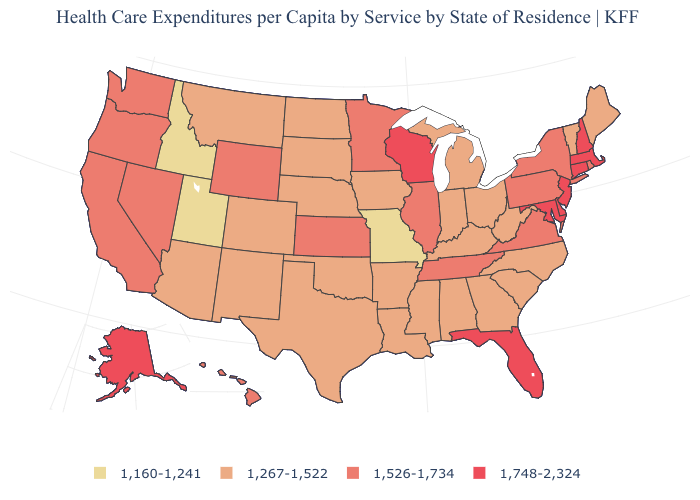Does Utah have the lowest value in the USA?
Write a very short answer. Yes. Name the states that have a value in the range 1,526-1,734?
Be succinct. California, Hawaii, Illinois, Kansas, Minnesota, Nevada, New York, Oregon, Pennsylvania, Rhode Island, Tennessee, Virginia, Washington, Wyoming. Which states have the lowest value in the USA?
Short answer required. Idaho, Missouri, Utah. Which states have the highest value in the USA?
Answer briefly. Alaska, Connecticut, Delaware, Florida, Maryland, Massachusetts, New Hampshire, New Jersey, Wisconsin. Which states hav the highest value in the MidWest?
Be succinct. Wisconsin. What is the value of Florida?
Short answer required. 1,748-2,324. Which states hav the highest value in the MidWest?
Quick response, please. Wisconsin. What is the value of Alaska?
Give a very brief answer. 1,748-2,324. What is the value of New Jersey?
Keep it brief. 1,748-2,324. Name the states that have a value in the range 1,267-1,522?
Quick response, please. Alabama, Arizona, Arkansas, Colorado, Georgia, Indiana, Iowa, Kentucky, Louisiana, Maine, Michigan, Mississippi, Montana, Nebraska, New Mexico, North Carolina, North Dakota, Ohio, Oklahoma, South Carolina, South Dakota, Texas, Vermont, West Virginia. Name the states that have a value in the range 1,267-1,522?
Short answer required. Alabama, Arizona, Arkansas, Colorado, Georgia, Indiana, Iowa, Kentucky, Louisiana, Maine, Michigan, Mississippi, Montana, Nebraska, New Mexico, North Carolina, North Dakota, Ohio, Oklahoma, South Carolina, South Dakota, Texas, Vermont, West Virginia. Which states have the highest value in the USA?
Quick response, please. Alaska, Connecticut, Delaware, Florida, Maryland, Massachusetts, New Hampshire, New Jersey, Wisconsin. Among the states that border Minnesota , which have the highest value?
Answer briefly. Wisconsin. Does Massachusetts have the lowest value in the Northeast?
Be succinct. No. What is the highest value in the USA?
Quick response, please. 1,748-2,324. 